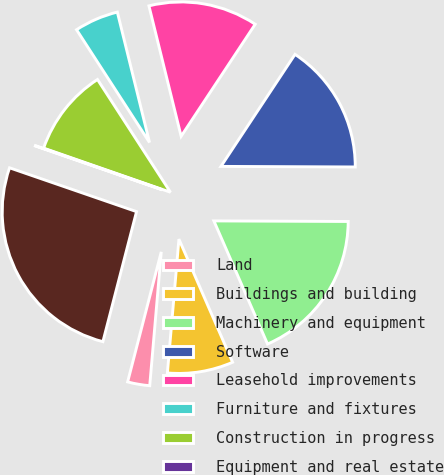Convert chart to OTSL. <chart><loc_0><loc_0><loc_500><loc_500><pie_chart><fcel>Land<fcel>Buildings and building<fcel>Machinery and equipment<fcel>Software<fcel>Leasehold improvements<fcel>Furniture and fixtures<fcel>Construction in progress<fcel>Equipment and real estate<fcel>Less accumulated depreciation<nl><fcel>2.66%<fcel>7.91%<fcel>18.39%<fcel>15.77%<fcel>13.15%<fcel>5.29%<fcel>10.53%<fcel>0.04%<fcel>26.26%<nl></chart> 